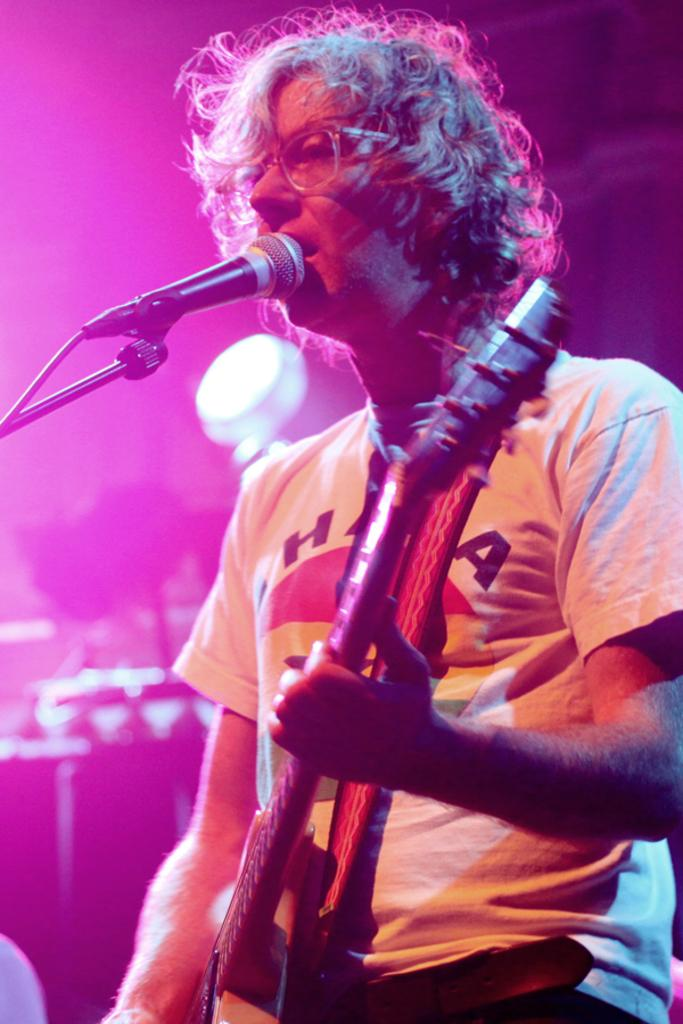What is the person in the image doing? The person in the image is playing a guitar. What else is the person doing while playing the guitar? The person is singing a song. What device is the person using to amplify their voice? The person is using a microphone. What type of receipt can be seen in the image? There is no receipt present in the image. How many brothers are visible in the image? There are no brothers present in the image. 